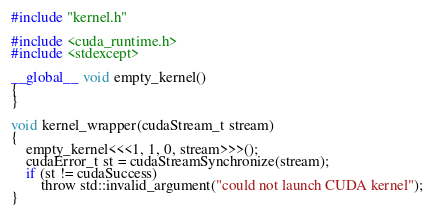Convert code to text. <code><loc_0><loc_0><loc_500><loc_500><_Cuda_>#include "kernel.h"

#include <cuda_runtime.h>
#include <stdexcept>

__global__ void empty_kernel()
{
}

void kernel_wrapper(cudaStream_t stream)
{
    empty_kernel<<<1, 1, 0, stream>>>();
    cudaError_t st = cudaStreamSynchronize(stream);
    if (st != cudaSuccess)
        throw std::invalid_argument("could not launch CUDA kernel");
}
</code> 